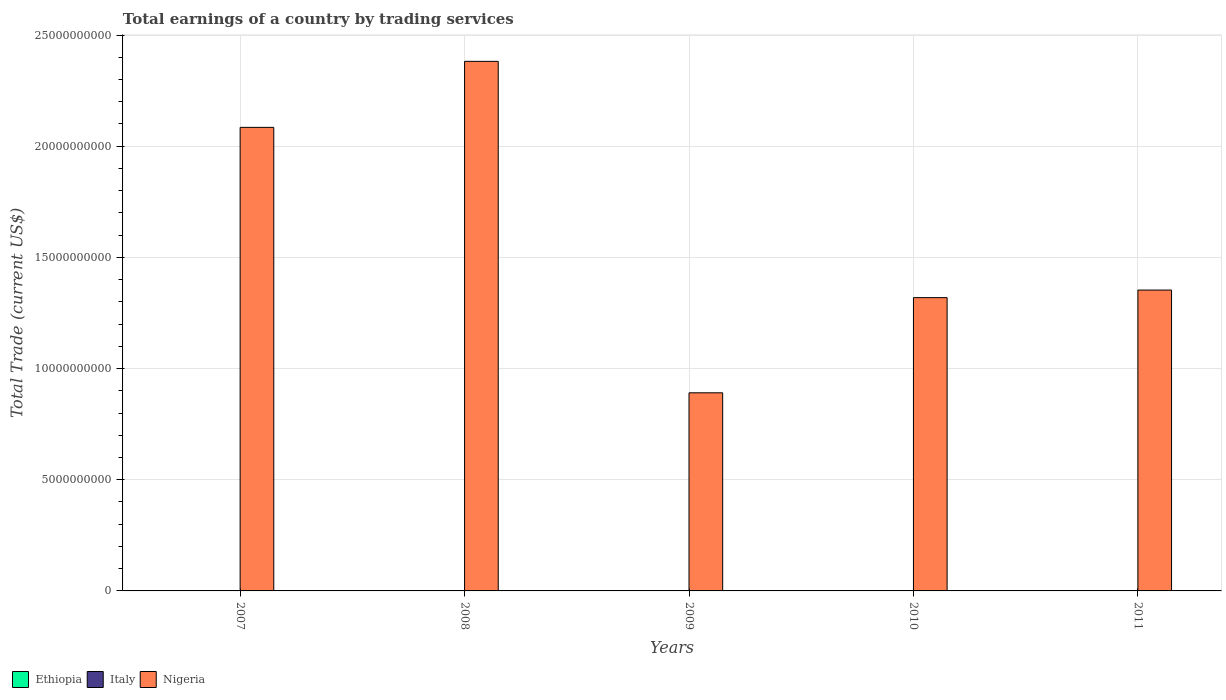How many different coloured bars are there?
Offer a very short reply. 1. Are the number of bars on each tick of the X-axis equal?
Ensure brevity in your answer.  Yes. How many bars are there on the 4th tick from the right?
Your answer should be very brief. 1. What is the label of the 5th group of bars from the left?
Provide a succinct answer. 2011. What is the total earnings in Nigeria in 2007?
Your answer should be compact. 2.08e+1. Across all years, what is the maximum total earnings in Nigeria?
Your answer should be very brief. 2.38e+1. Across all years, what is the minimum total earnings in Nigeria?
Ensure brevity in your answer.  8.91e+09. What is the total total earnings in Nigeria in the graph?
Provide a succinct answer. 8.03e+1. What is the difference between the total earnings in Nigeria in 2007 and that in 2011?
Your response must be concise. 7.32e+09. What is the difference between the total earnings in Ethiopia in 2010 and the total earnings in Italy in 2009?
Offer a terse response. 0. What is the average total earnings in Nigeria per year?
Offer a terse response. 1.61e+1. What is the ratio of the total earnings in Nigeria in 2010 to that in 2011?
Your response must be concise. 0.97. What is the difference between the highest and the second highest total earnings in Nigeria?
Your answer should be compact. 2.97e+09. What is the difference between the highest and the lowest total earnings in Nigeria?
Keep it short and to the point. 1.49e+1. In how many years, is the total earnings in Ethiopia greater than the average total earnings in Ethiopia taken over all years?
Ensure brevity in your answer.  0. Is it the case that in every year, the sum of the total earnings in Ethiopia and total earnings in Nigeria is greater than the total earnings in Italy?
Give a very brief answer. Yes. Are all the bars in the graph horizontal?
Offer a terse response. No. Where does the legend appear in the graph?
Your response must be concise. Bottom left. How are the legend labels stacked?
Offer a terse response. Horizontal. What is the title of the graph?
Your response must be concise. Total earnings of a country by trading services. Does "Tanzania" appear as one of the legend labels in the graph?
Your answer should be very brief. No. What is the label or title of the X-axis?
Provide a succinct answer. Years. What is the label or title of the Y-axis?
Ensure brevity in your answer.  Total Trade (current US$). What is the Total Trade (current US$) in Ethiopia in 2007?
Ensure brevity in your answer.  0. What is the Total Trade (current US$) of Nigeria in 2007?
Your response must be concise. 2.08e+1. What is the Total Trade (current US$) of Nigeria in 2008?
Make the answer very short. 2.38e+1. What is the Total Trade (current US$) in Italy in 2009?
Your answer should be very brief. 0. What is the Total Trade (current US$) of Nigeria in 2009?
Your answer should be compact. 8.91e+09. What is the Total Trade (current US$) in Ethiopia in 2010?
Ensure brevity in your answer.  0. What is the Total Trade (current US$) in Nigeria in 2010?
Offer a terse response. 1.32e+1. What is the Total Trade (current US$) in Italy in 2011?
Ensure brevity in your answer.  0. What is the Total Trade (current US$) in Nigeria in 2011?
Offer a very short reply. 1.35e+1. Across all years, what is the maximum Total Trade (current US$) of Nigeria?
Make the answer very short. 2.38e+1. Across all years, what is the minimum Total Trade (current US$) of Nigeria?
Provide a short and direct response. 8.91e+09. What is the total Total Trade (current US$) of Ethiopia in the graph?
Give a very brief answer. 0. What is the total Total Trade (current US$) of Italy in the graph?
Ensure brevity in your answer.  0. What is the total Total Trade (current US$) of Nigeria in the graph?
Your answer should be very brief. 8.03e+1. What is the difference between the Total Trade (current US$) in Nigeria in 2007 and that in 2008?
Make the answer very short. -2.97e+09. What is the difference between the Total Trade (current US$) of Nigeria in 2007 and that in 2009?
Make the answer very short. 1.19e+1. What is the difference between the Total Trade (current US$) of Nigeria in 2007 and that in 2010?
Give a very brief answer. 7.66e+09. What is the difference between the Total Trade (current US$) in Nigeria in 2007 and that in 2011?
Give a very brief answer. 7.32e+09. What is the difference between the Total Trade (current US$) in Nigeria in 2008 and that in 2009?
Your response must be concise. 1.49e+1. What is the difference between the Total Trade (current US$) of Nigeria in 2008 and that in 2010?
Give a very brief answer. 1.06e+1. What is the difference between the Total Trade (current US$) in Nigeria in 2008 and that in 2011?
Offer a very short reply. 1.03e+1. What is the difference between the Total Trade (current US$) of Nigeria in 2009 and that in 2010?
Give a very brief answer. -4.28e+09. What is the difference between the Total Trade (current US$) in Nigeria in 2009 and that in 2011?
Keep it short and to the point. -4.62e+09. What is the difference between the Total Trade (current US$) of Nigeria in 2010 and that in 2011?
Give a very brief answer. -3.40e+08. What is the average Total Trade (current US$) of Italy per year?
Your response must be concise. 0. What is the average Total Trade (current US$) of Nigeria per year?
Make the answer very short. 1.61e+1. What is the ratio of the Total Trade (current US$) in Nigeria in 2007 to that in 2008?
Your answer should be compact. 0.88. What is the ratio of the Total Trade (current US$) of Nigeria in 2007 to that in 2009?
Make the answer very short. 2.34. What is the ratio of the Total Trade (current US$) of Nigeria in 2007 to that in 2010?
Offer a very short reply. 1.58. What is the ratio of the Total Trade (current US$) of Nigeria in 2007 to that in 2011?
Give a very brief answer. 1.54. What is the ratio of the Total Trade (current US$) in Nigeria in 2008 to that in 2009?
Give a very brief answer. 2.67. What is the ratio of the Total Trade (current US$) in Nigeria in 2008 to that in 2010?
Offer a very short reply. 1.81. What is the ratio of the Total Trade (current US$) in Nigeria in 2008 to that in 2011?
Provide a short and direct response. 1.76. What is the ratio of the Total Trade (current US$) of Nigeria in 2009 to that in 2010?
Offer a very short reply. 0.68. What is the ratio of the Total Trade (current US$) of Nigeria in 2009 to that in 2011?
Your answer should be very brief. 0.66. What is the ratio of the Total Trade (current US$) of Nigeria in 2010 to that in 2011?
Provide a succinct answer. 0.97. What is the difference between the highest and the second highest Total Trade (current US$) of Nigeria?
Offer a very short reply. 2.97e+09. What is the difference between the highest and the lowest Total Trade (current US$) in Nigeria?
Keep it short and to the point. 1.49e+1. 